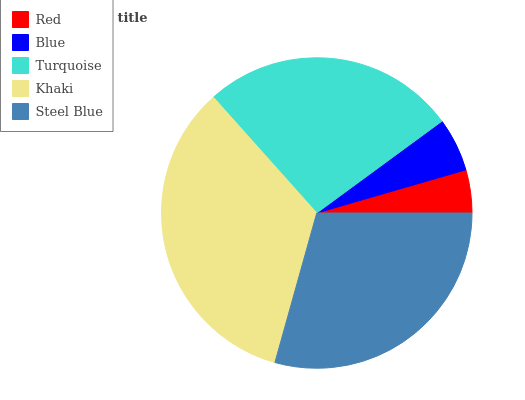Is Red the minimum?
Answer yes or no. Yes. Is Khaki the maximum?
Answer yes or no. Yes. Is Blue the minimum?
Answer yes or no. No. Is Blue the maximum?
Answer yes or no. No. Is Blue greater than Red?
Answer yes or no. Yes. Is Red less than Blue?
Answer yes or no. Yes. Is Red greater than Blue?
Answer yes or no. No. Is Blue less than Red?
Answer yes or no. No. Is Turquoise the high median?
Answer yes or no. Yes. Is Turquoise the low median?
Answer yes or no. Yes. Is Blue the high median?
Answer yes or no. No. Is Blue the low median?
Answer yes or no. No. 